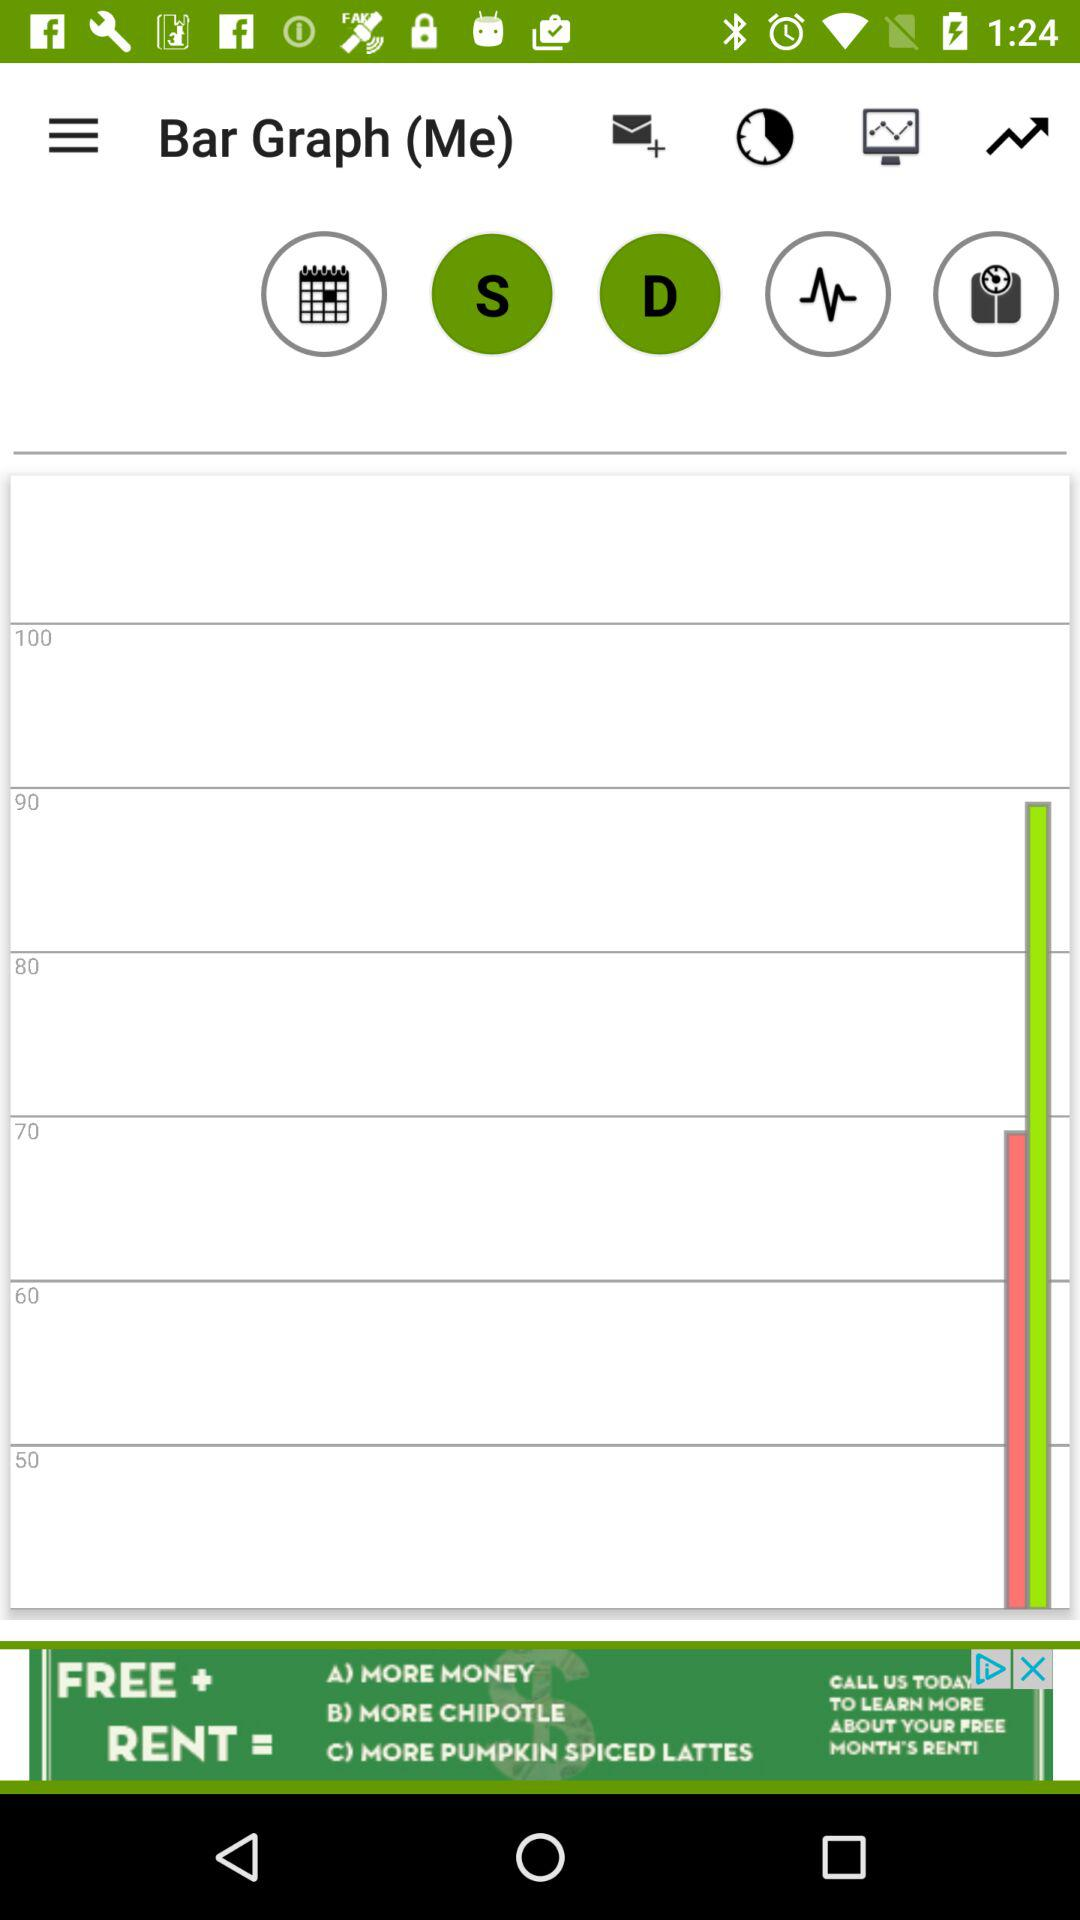What is the difference between the highest and lowest score on the timeline?
Answer the question using a single word or phrase. 50 